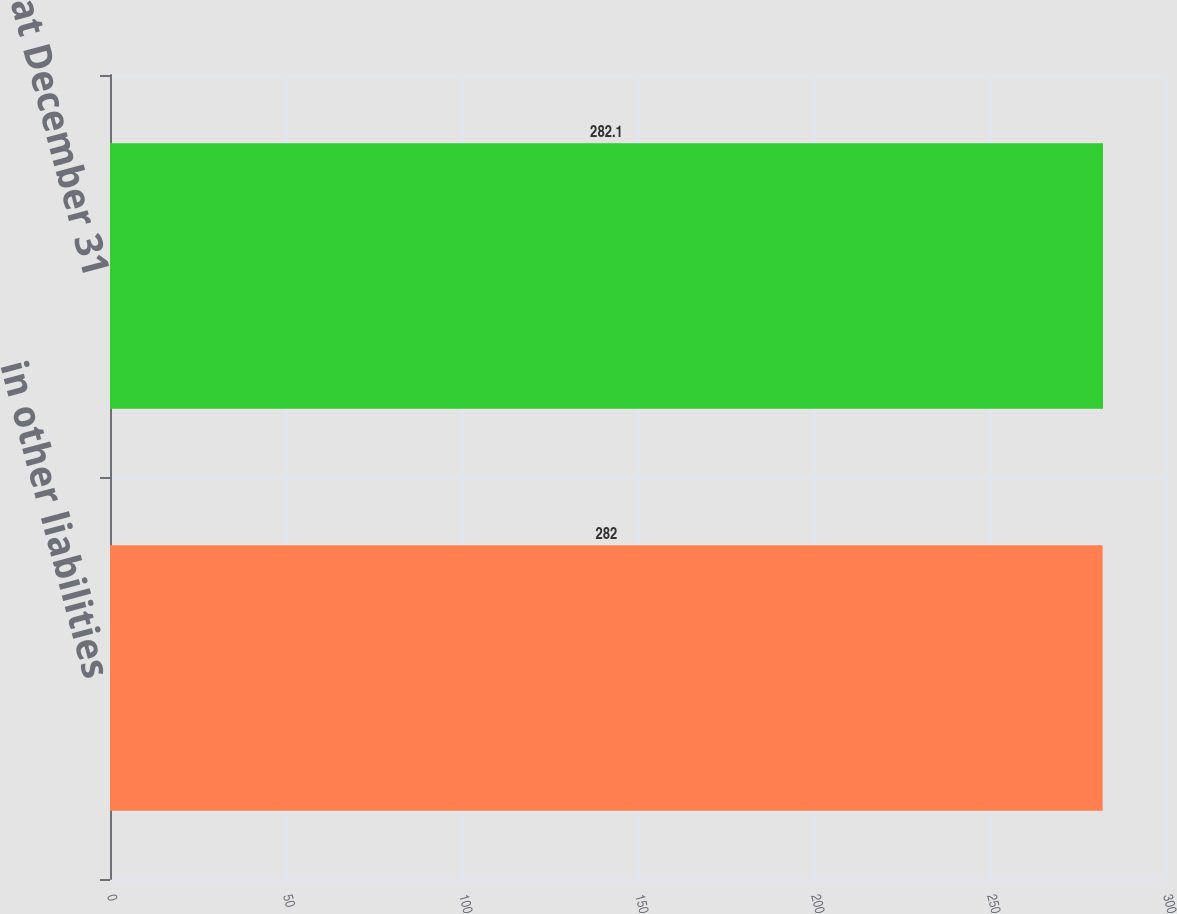Convert chart to OTSL. <chart><loc_0><loc_0><loc_500><loc_500><bar_chart><fcel>in other liabilities<fcel>at December 31<nl><fcel>282<fcel>282.1<nl></chart> 